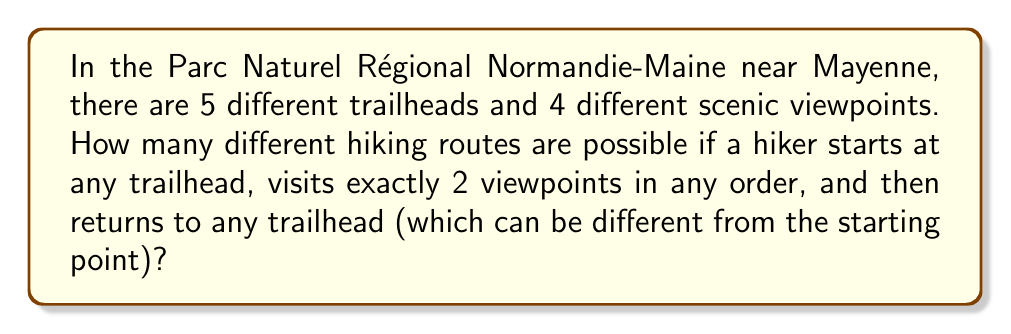Show me your answer to this math problem. Let's break this down step-by-step:

1) First, we need to choose a starting trailhead. There are 5 options for this.

2) Next, we need to choose 2 viewpoints out of 4. This is a combination problem. The number of ways to choose 2 items from 4 is given by the combination formula:

   $$\binom{4}{2} = \frac{4!}{2!(4-2)!} = \frac{4 \cdot 3}{2 \cdot 1} = 6$$

3) The order in which we visit these 2 viewpoints matters. For any 2 chosen viewpoints, there are 2! = 2 ways to order them.

4) Finally, we need to choose an ending trailhead. There are 5 options for this.

5) By the multiplication principle, we multiply all these choices together:

   $$5 \cdot \binom{4}{2} \cdot 2! \cdot 5 = 5 \cdot 6 \cdot 2 \cdot 5 = 300$$

Therefore, there are 300 different possible hiking routes.
Answer: 300 